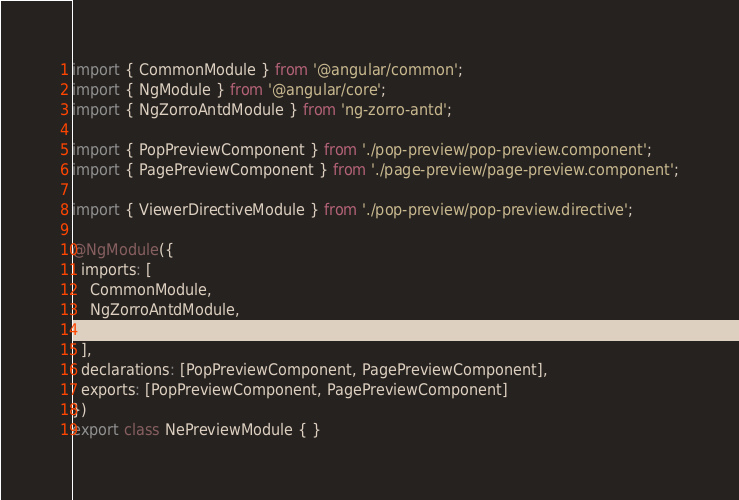<code> <loc_0><loc_0><loc_500><loc_500><_TypeScript_>import { CommonModule } from '@angular/common';
import { NgModule } from '@angular/core';
import { NgZorroAntdModule } from 'ng-zorro-antd';

import { PopPreviewComponent } from './pop-preview/pop-preview.component';
import { PagePreviewComponent } from './page-preview/page-preview.component';

import { ViewerDirectiveModule } from './pop-preview/pop-preview.directive';

@NgModule({
  imports: [
    CommonModule,
    NgZorroAntdModule,
    ViewerDirectiveModule
  ],
  declarations: [PopPreviewComponent, PagePreviewComponent],
  exports: [PopPreviewComponent, PagePreviewComponent]
})
export class NePreviewModule { }
</code> 